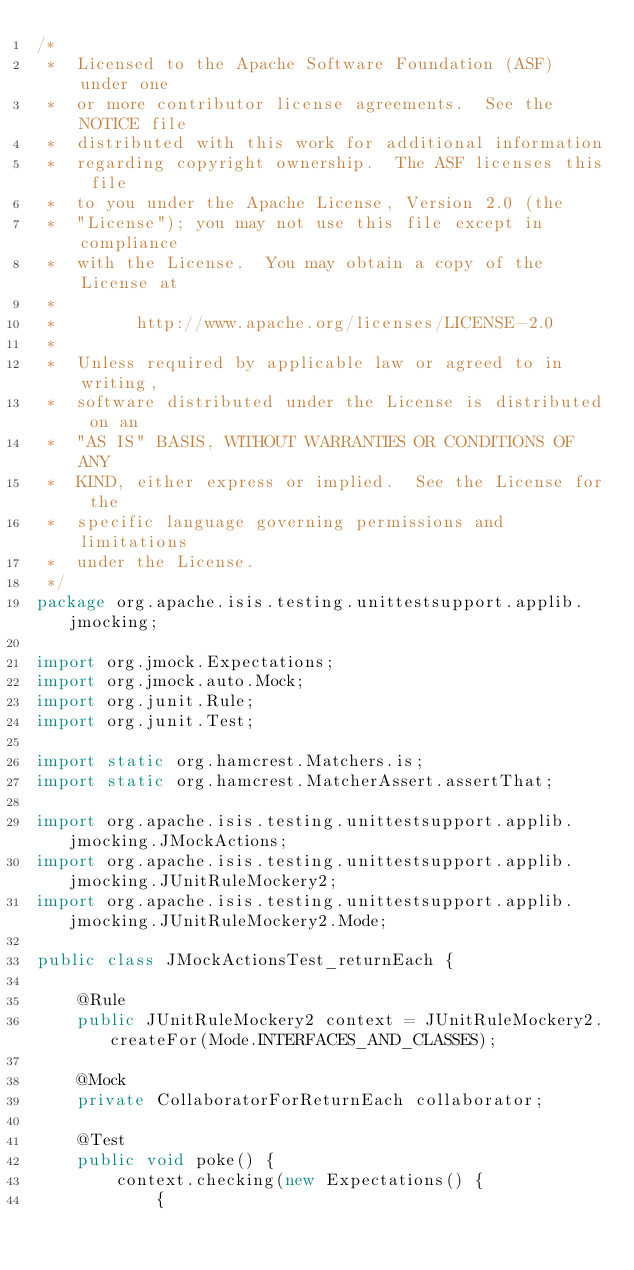<code> <loc_0><loc_0><loc_500><loc_500><_Java_>/*
 *  Licensed to the Apache Software Foundation (ASF) under one
 *  or more contributor license agreements.  See the NOTICE file
 *  distributed with this work for additional information
 *  regarding copyright ownership.  The ASF licenses this file
 *  to you under the Apache License, Version 2.0 (the
 *  "License"); you may not use this file except in compliance
 *  with the License.  You may obtain a copy of the License at
 *
 *        http://www.apache.org/licenses/LICENSE-2.0
 *
 *  Unless required by applicable law or agreed to in writing,
 *  software distributed under the License is distributed on an
 *  "AS IS" BASIS, WITHOUT WARRANTIES OR CONDITIONS OF ANY
 *  KIND, either express or implied.  See the License for the
 *  specific language governing permissions and limitations
 *  under the License.
 */
package org.apache.isis.testing.unittestsupport.applib.jmocking;

import org.jmock.Expectations;
import org.jmock.auto.Mock;
import org.junit.Rule;
import org.junit.Test;

import static org.hamcrest.Matchers.is;
import static org.hamcrest.MatcherAssert.assertThat;

import org.apache.isis.testing.unittestsupport.applib.jmocking.JMockActions;
import org.apache.isis.testing.unittestsupport.applib.jmocking.JUnitRuleMockery2;
import org.apache.isis.testing.unittestsupport.applib.jmocking.JUnitRuleMockery2.Mode;

public class JMockActionsTest_returnEach {

    @Rule
    public JUnitRuleMockery2 context = JUnitRuleMockery2.createFor(Mode.INTERFACES_AND_CLASSES);

    @Mock
    private CollaboratorForReturnEach collaborator;

    @Test
    public void poke() {
        context.checking(new Expectations() {
            {</code> 